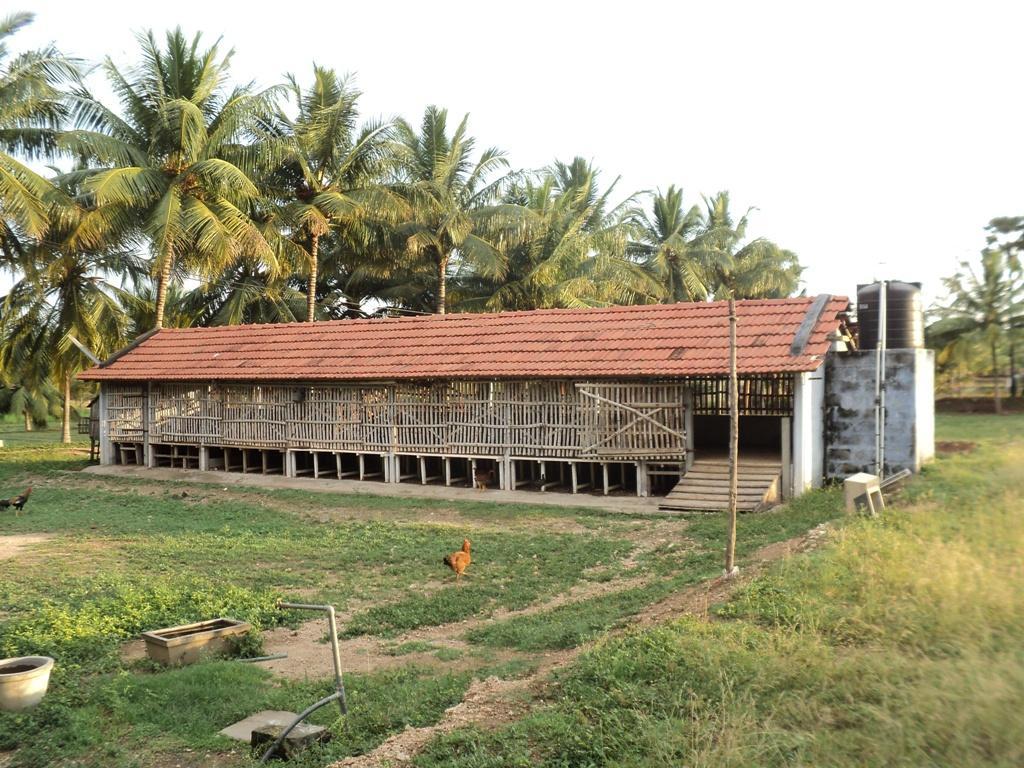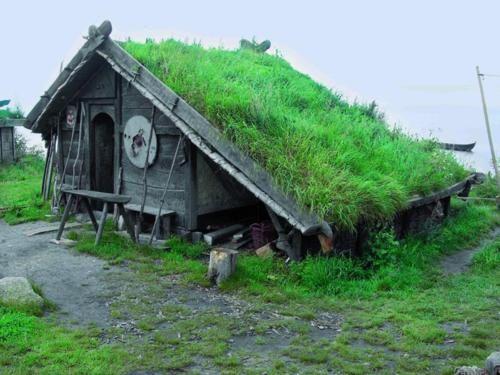The first image is the image on the left, the second image is the image on the right. Analyze the images presented: Is the assertion "In at least one image there is a building with a black hay roof." valid? Answer yes or no. No. The first image is the image on the left, the second image is the image on the right. Analyze the images presented: Is the assertion "One house is shaped like a triangle." valid? Answer yes or no. Yes. 